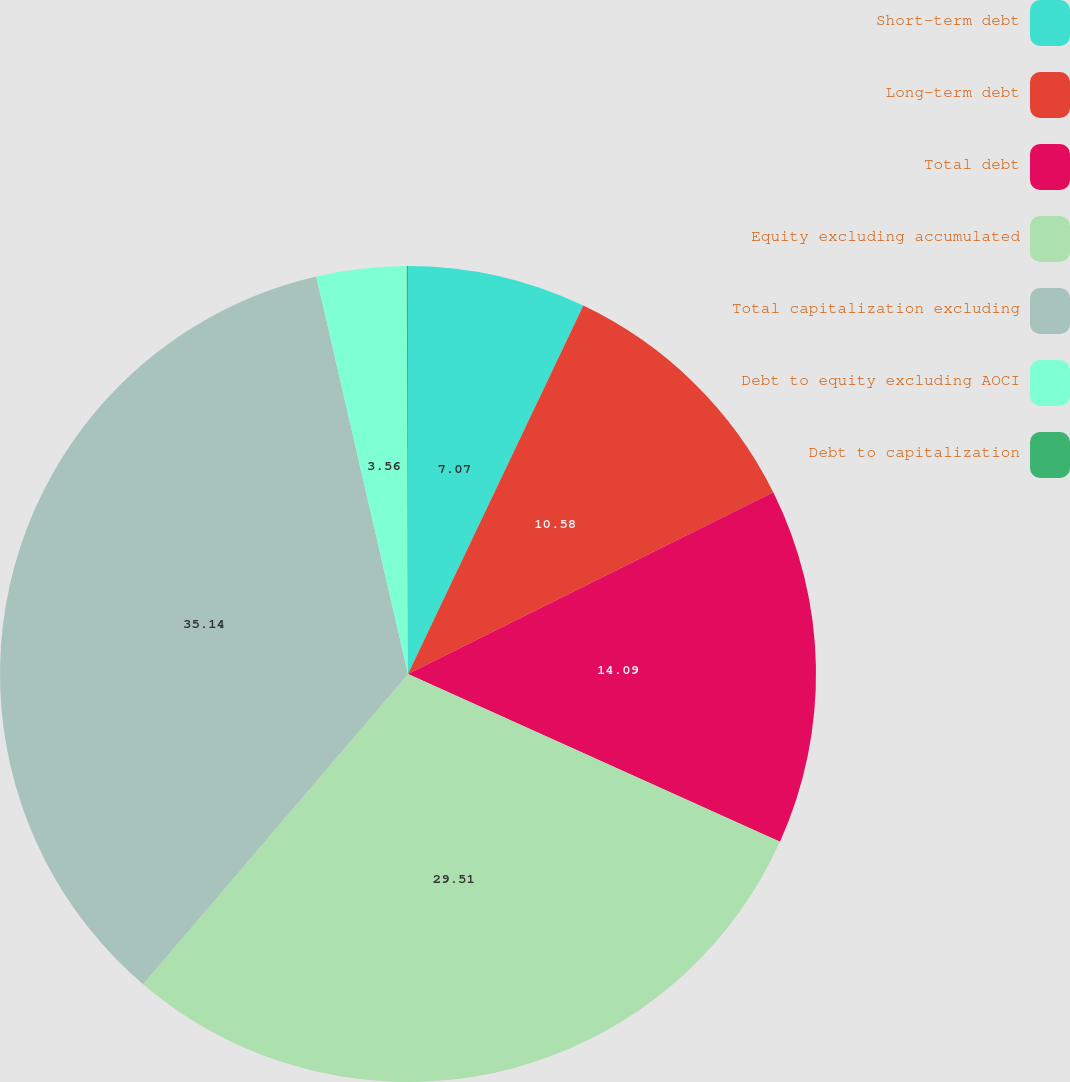Convert chart. <chart><loc_0><loc_0><loc_500><loc_500><pie_chart><fcel>Short-term debt<fcel>Long-term debt<fcel>Total debt<fcel>Equity excluding accumulated<fcel>Total capitalization excluding<fcel>Debt to equity excluding AOCI<fcel>Debt to capitalization<nl><fcel>7.07%<fcel>10.58%<fcel>14.09%<fcel>29.51%<fcel>35.14%<fcel>3.56%<fcel>0.05%<nl></chart> 